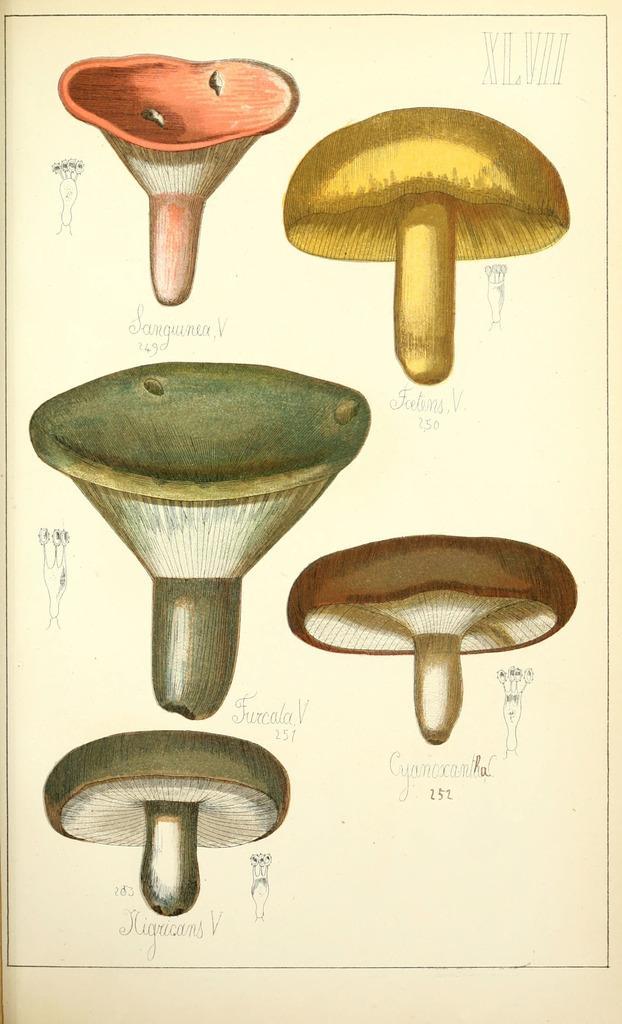Can you describe this image briefly? In this image I can see there are mushrooms. 